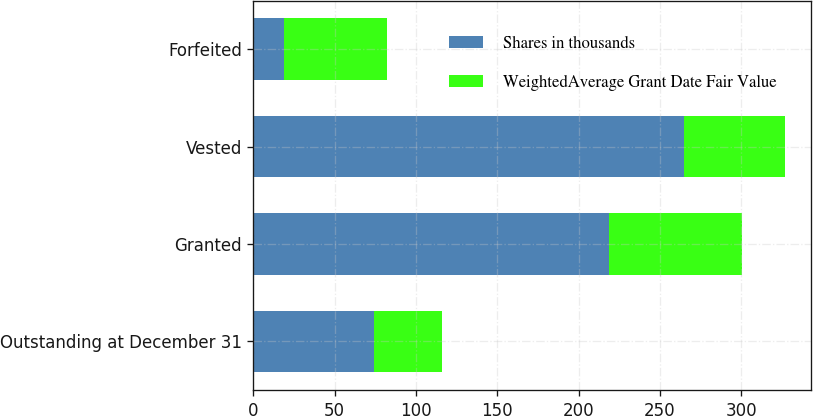Convert chart to OTSL. <chart><loc_0><loc_0><loc_500><loc_500><stacked_bar_chart><ecel><fcel>Outstanding at December 31<fcel>Granted<fcel>Vested<fcel>Forfeited<nl><fcel>Shares in thousands<fcel>73.95<fcel>219<fcel>265<fcel>19<nl><fcel>WeightedAverage Grant Date Fair Value<fcel>41.87<fcel>81.7<fcel>61.95<fcel>63.03<nl></chart> 